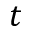<formula> <loc_0><loc_0><loc_500><loc_500>t</formula> 